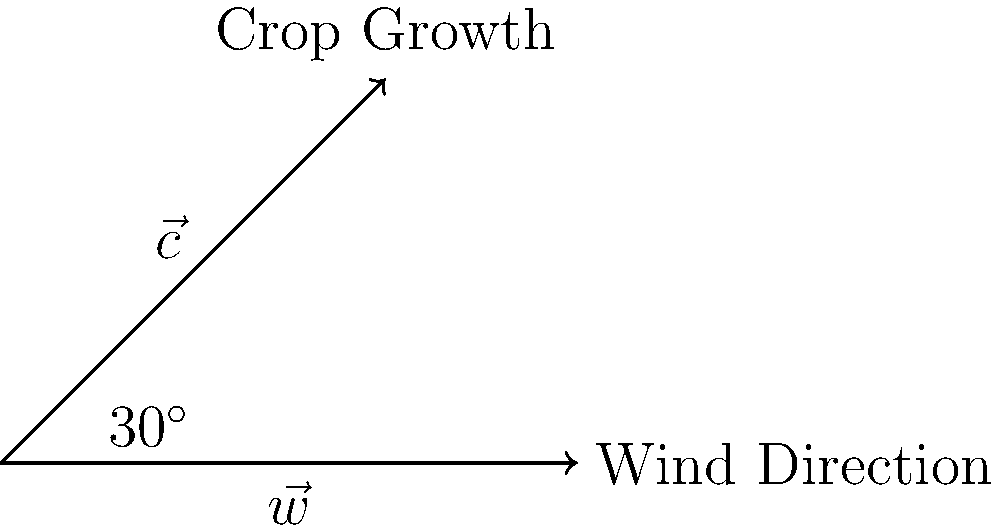In Morrison's cornfield, the wind direction vector $\vec{w}$ has a magnitude of 15 mph and is represented by the horizontal arrow. The crop growth vector $\vec{c}$ has a magnitude of 8 inches per day and is shown at a $30^\circ$ angle from the wind direction. Calculate the dot product of these two vectors to determine how the wind affects crop growth. To calculate the dot product of the wind direction vector $\vec{w}$ and the crop growth vector $\vec{c}$, we'll follow these steps:

1) Recall the formula for the dot product:
   $\vec{w} \cdot \vec{c} = |\vec{w}||\vec{c}|\cos\theta$

2) We're given:
   $|\vec{w}| = 15$ mph
   $|\vec{c}| = 8$ inches/day
   $\theta = 30^\circ$

3) Substitute these values into the formula:
   $\vec{w} \cdot \vec{c} = (15)(8)\cos(30^\circ)$

4) Calculate $\cos(30^\circ)$:
   $\cos(30^\circ) = \frac{\sqrt{3}}{2} \approx 0.866$

5) Complete the calculation:
   $\vec{w} \cdot \vec{c} = (15)(8)(0.866) = 103.92$

The units of the result are (mph)(inches/day), which represents the influence of wind speed on daily crop growth.
Answer: $103.92$ (mph)(inches/day) 